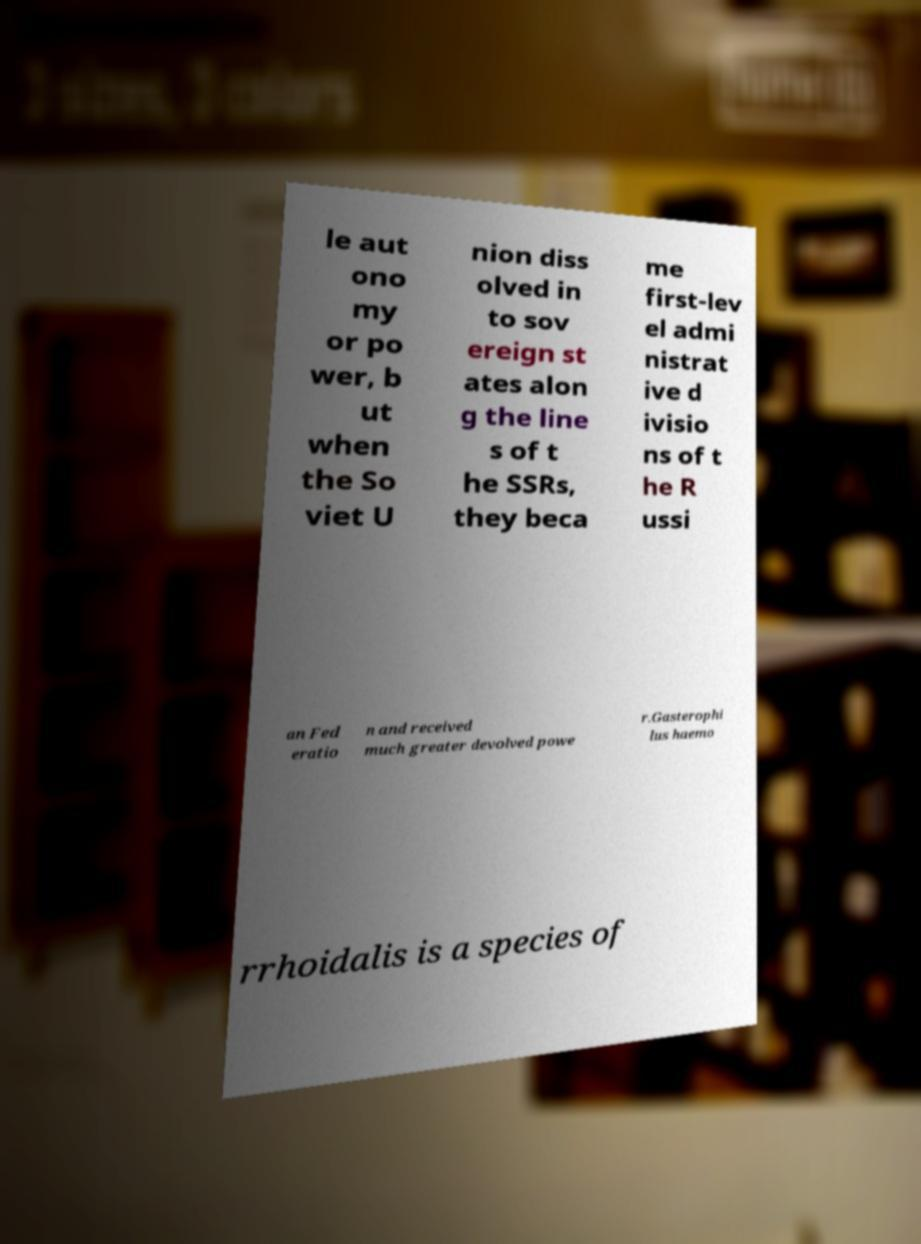There's text embedded in this image that I need extracted. Can you transcribe it verbatim? le aut ono my or po wer, b ut when the So viet U nion diss olved in to sov ereign st ates alon g the line s of t he SSRs, they beca me first-lev el admi nistrat ive d ivisio ns of t he R ussi an Fed eratio n and received much greater devolved powe r.Gasterophi lus haemo rrhoidalis is a species of 